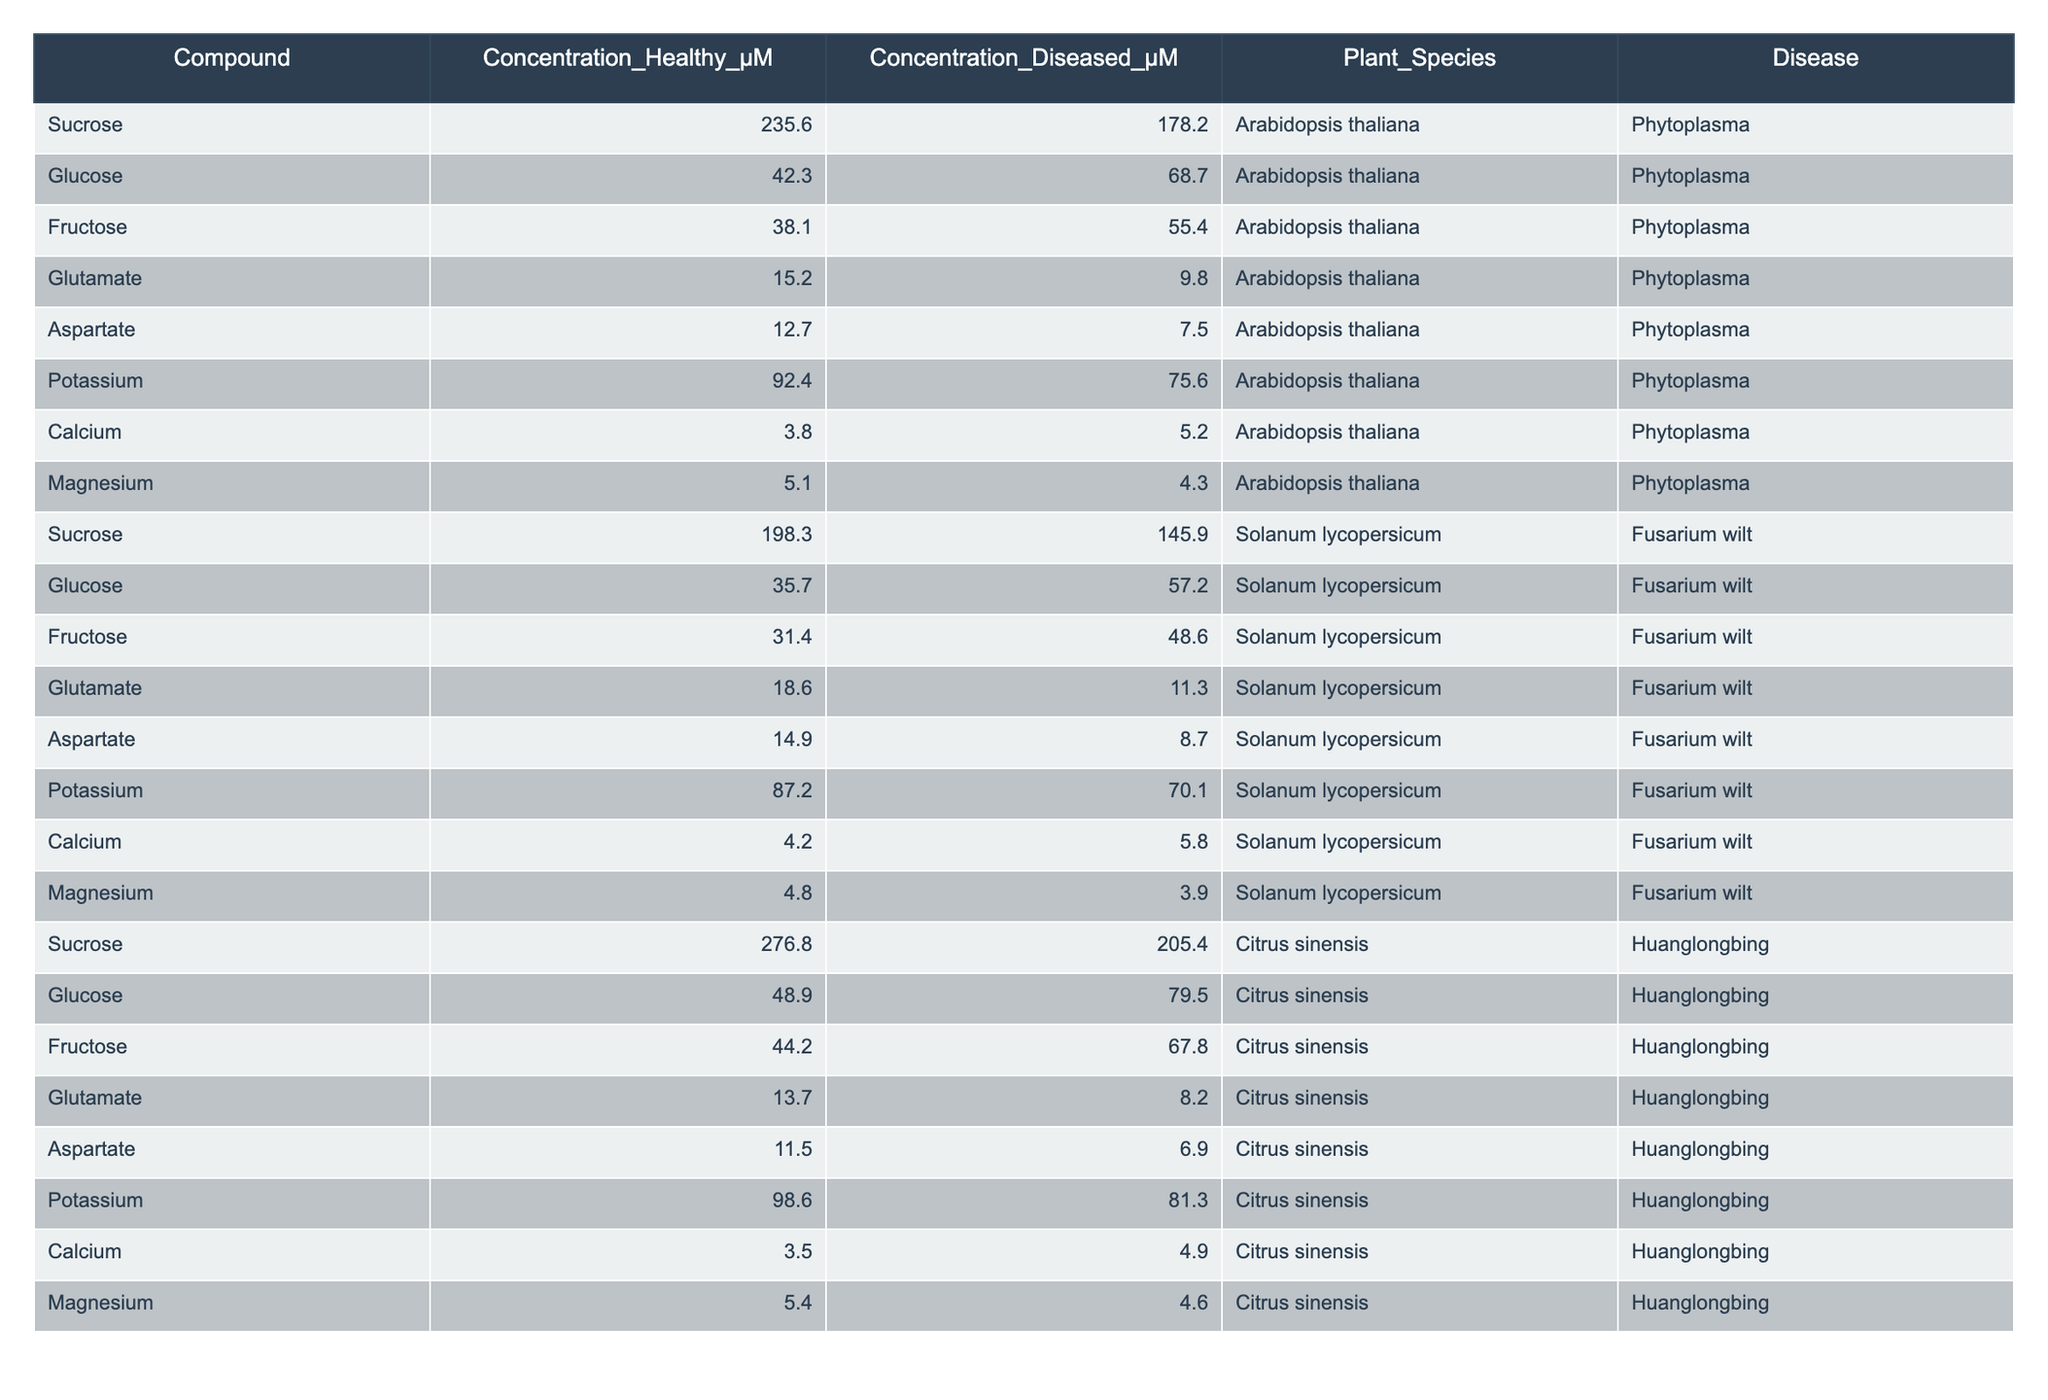What is the concentration of sucrose in healthy Arabidopsis thaliana plants? The table indicates that the concentration of sucrose in healthy Arabidopsis thaliana is 235.6 μM.
Answer: 235.6 μM What is the difference in glucose concentration between healthy and diseased Solanum lycopersicum? For healthy Solanum lycopersicum, the glucose concentration is 35.7 μM, and for diseased, it is 57.2 μM. The difference is 57.2 - 35.7 = 21.5 μM.
Answer: 21.5 μM Is the concentration of potassium higher in healthy or diseased Citrus sinensis? The concentration of potassium in healthy Citrus sinensis is 98.6 μM, while in diseased it is 81.3 μM, indicating that it is higher in the healthy plants.
Answer: Yes, it's higher in healthy plants What is the total concentration of glucose present in healthy plants across all species? The glucose concentrations are 42.3 μM (Arabidopsis thaliana) + 35.7 μM (Solanum lycopersicum) + 48.9 μM (Citrus sinensis) = 126.9 μM total.
Answer: 126.9 μM Which compound shows the greatest decrease in concentration from healthy to diseased plants in Arabidopsis thaliana? Reviewing the values, sucrose decreases from 235.6 μM to 178.2 μM, which is a difference of 57.4 μM. Glucose decreases from 42.3 μM to 68.7 μM (increase), so the greatest decrease is for sucrose.
Answer: Sucrose shows the greatest decrease What is the average concentration of fructose in healthy Citrus sinensis and Solanum lycopersicum combined? The healthy concentrations are 44.2 μM (Citrus sinensis) and 31.4 μM (Solanum lycopersicum). The average is (44.2 + 31.4) / 2 = 37.8 μM.
Answer: 37.8 μM For which plant species does aspartate concentration remain highest in diseased plants? Aspartate in diseased plants is 7.5 μM for Arabidopsis thaliana, 8.7 μM for Solanum lycopersicum, and 6.9 μM for Citrus sinensis. Thus, Solanum lycopersicum has the highest concentration.
Answer: Solanum lycopersicum What percentage decrease is observed in calcium concentration in Citrus sinensis from healthy to diseased? The concentration in healthy is 3.5 μM and in diseased is 4.9 μM. The decrease is calculated as ((3.5 - 4.9) / 3.5) × 100 = -40%. Since it's an increase, the decrease percentage is not applicable.
Answer: The calcium concentration actually increases, not decreases 